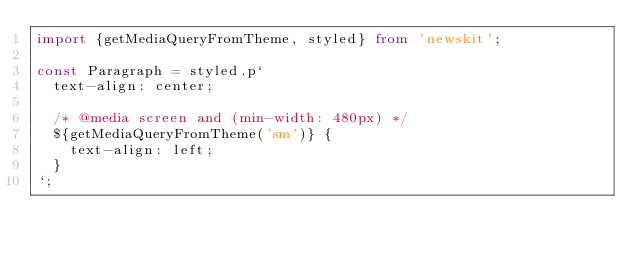Convert code to text. <code><loc_0><loc_0><loc_500><loc_500><_TypeScript_>import {getMediaQueryFromTheme, styled} from 'newskit';

const Paragraph = styled.p`
  text-align: center;

  /* @media screen and (min-width: 480px) */
  ${getMediaQueryFromTheme('sm')} {
    text-align: left;
  }
`;
</code> 